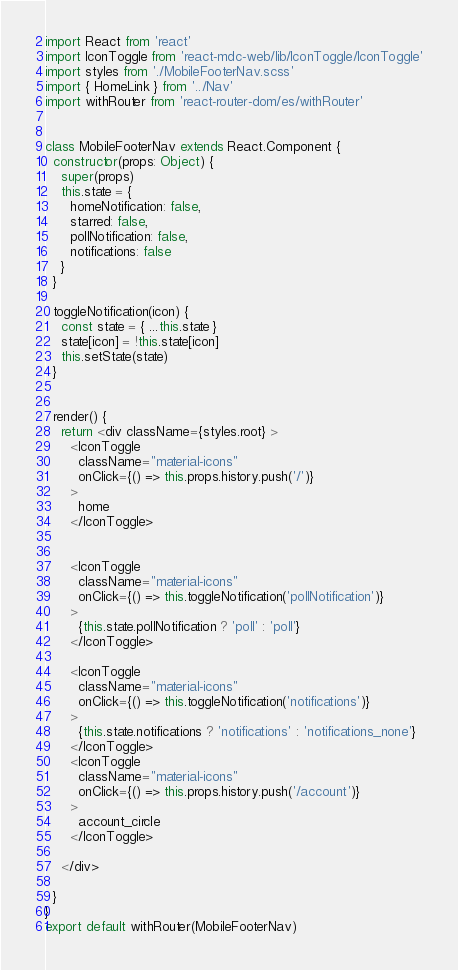Convert code to text. <code><loc_0><loc_0><loc_500><loc_500><_JavaScript_>import React from 'react'
import IconToggle from 'react-mdc-web/lib/IconToggle/IconToggle'
import styles from './MobileFooterNav.scss'
import { HomeLink } from '../Nav'
import withRouter from 'react-router-dom/es/withRouter'


class MobileFooterNav extends React.Component {
  constructor(props: Object) {
    super(props)
    this.state = {
      homeNotification: false,
      starred: false,
      pollNotification: false,
      notifications: false
    }
  }

  toggleNotification(icon) {
    const state = { ...this.state }
    state[icon] = !this.state[icon]
    this.setState(state)
  }


  render() {
    return <div className={styles.root} >
      <IconToggle
        className="material-icons"
        onClick={() => this.props.history.push('/')}
      >
        home
      </IconToggle>


      <IconToggle
        className="material-icons"
        onClick={() => this.toggleNotification('pollNotification')}
      >
        {this.state.pollNotification ? 'poll' : 'poll'}
      </IconToggle>

      <IconToggle
        className="material-icons"
        onClick={() => this.toggleNotification('notifications')}
      >
        {this.state.notifications ? 'notifications' : 'notifications_none'}
      </IconToggle>
      <IconToggle
        className="material-icons"
        onClick={() => this.props.history.push('/account')}
      >
        account_circle
      </IconToggle>

    </div>

  }
}
export default withRouter(MobileFooterNav)</code> 